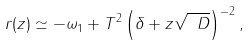Convert formula to latex. <formula><loc_0><loc_0><loc_500><loc_500>r ( z ) \simeq - \omega _ { 1 } + T ^ { 2 } \left ( \delta + z \sqrt { \ D } \right ) ^ { - 2 } ,</formula> 